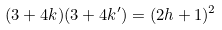Convert formula to latex. <formula><loc_0><loc_0><loc_500><loc_500>( 3 + 4 k ) ( 3 + 4 k ^ { \prime } ) = ( 2 h + 1 ) ^ { 2 }</formula> 